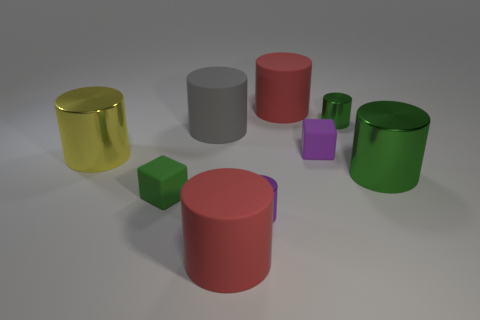Could the large red cylinder fit inside the gray cylinder without touching the sides? Given the perspective shown in the image, it is unlikely that the large red cylinder could fit entirely inside the gray cylinder without touching the sides because the red cylinder's diameter seems to be almost as wide as the gray one's internal diameter. However, without exact measurements, this can't be determined with certainty. 